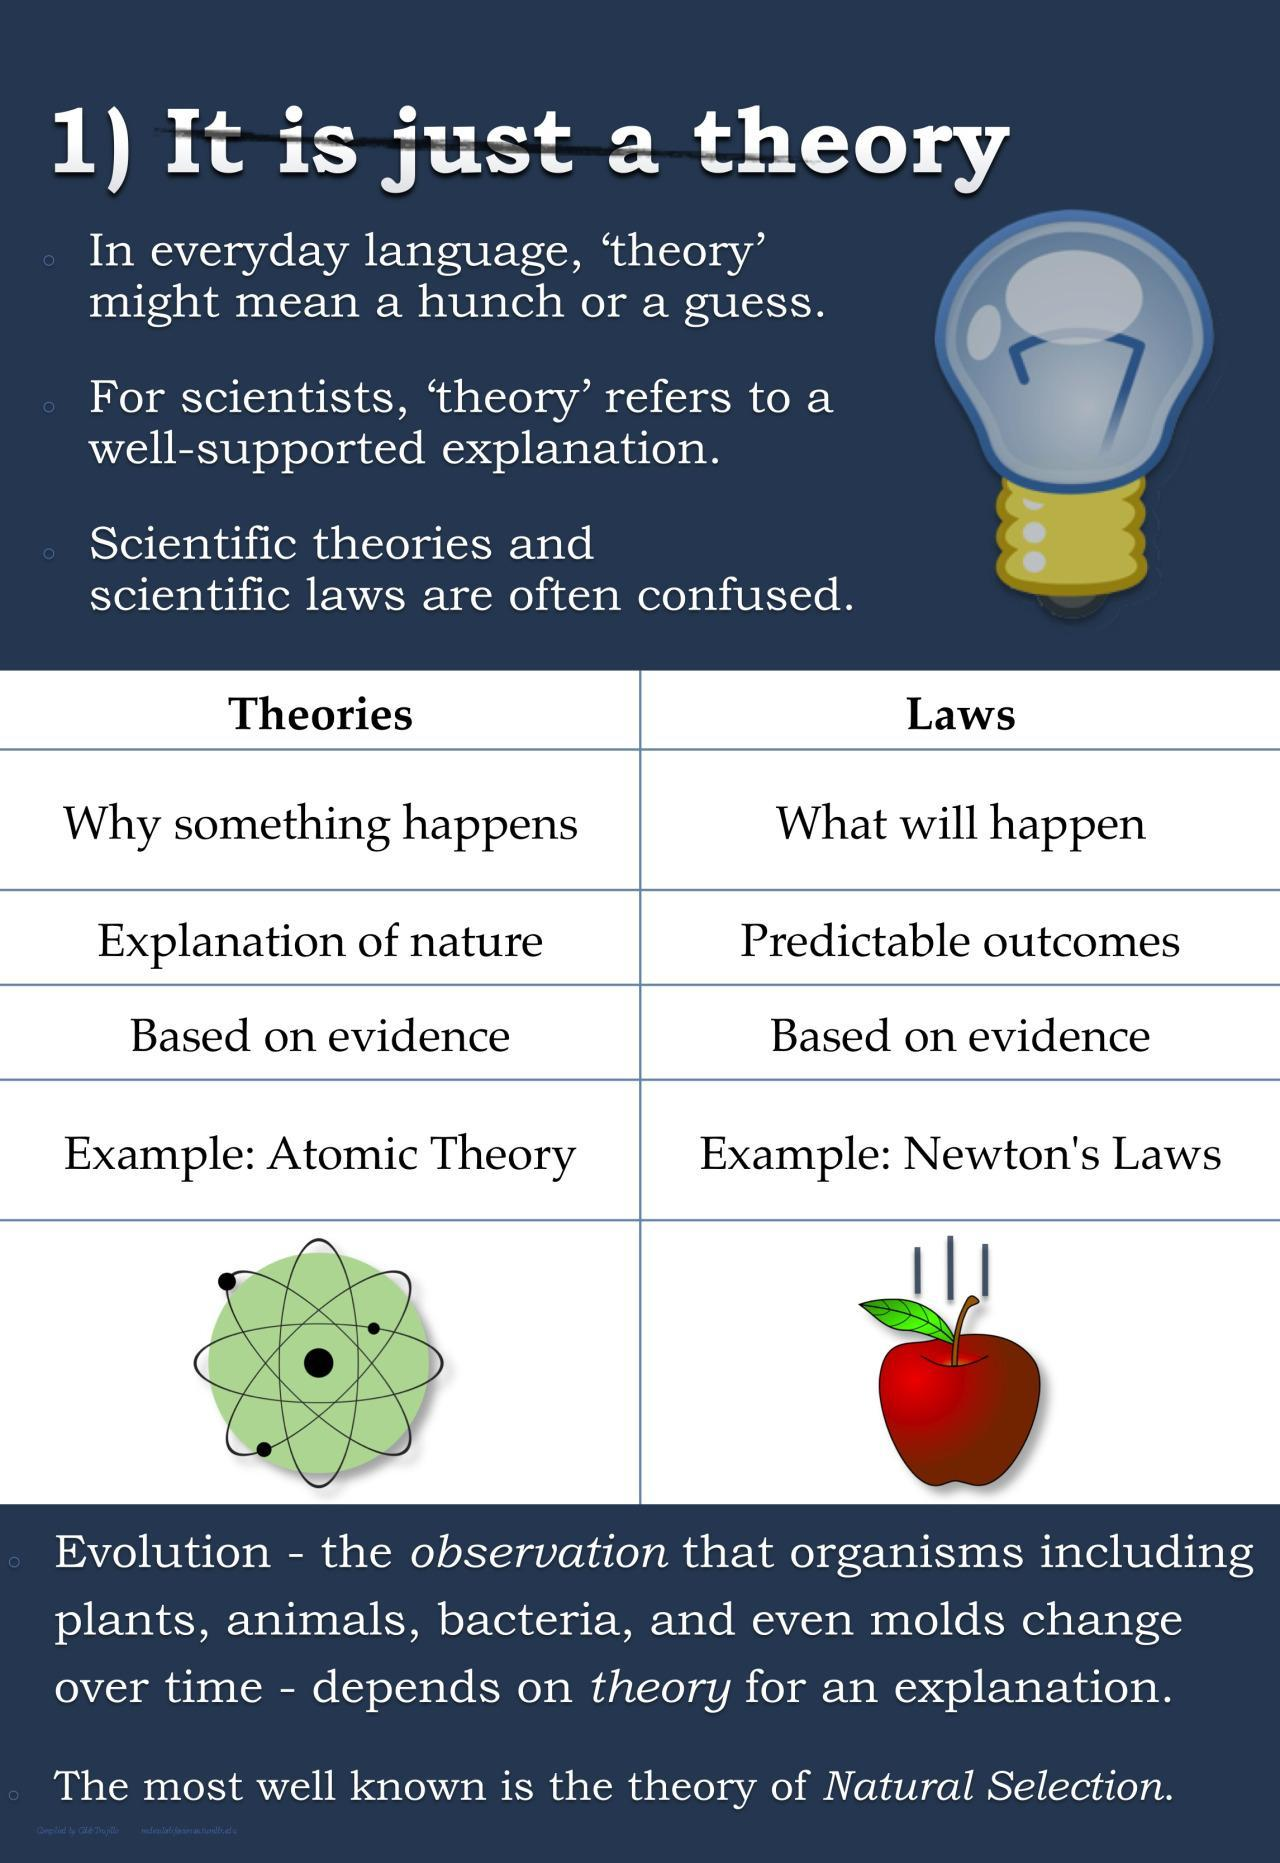How many theories mentioned in this infographic?
Answer the question with a short phrase. 2 